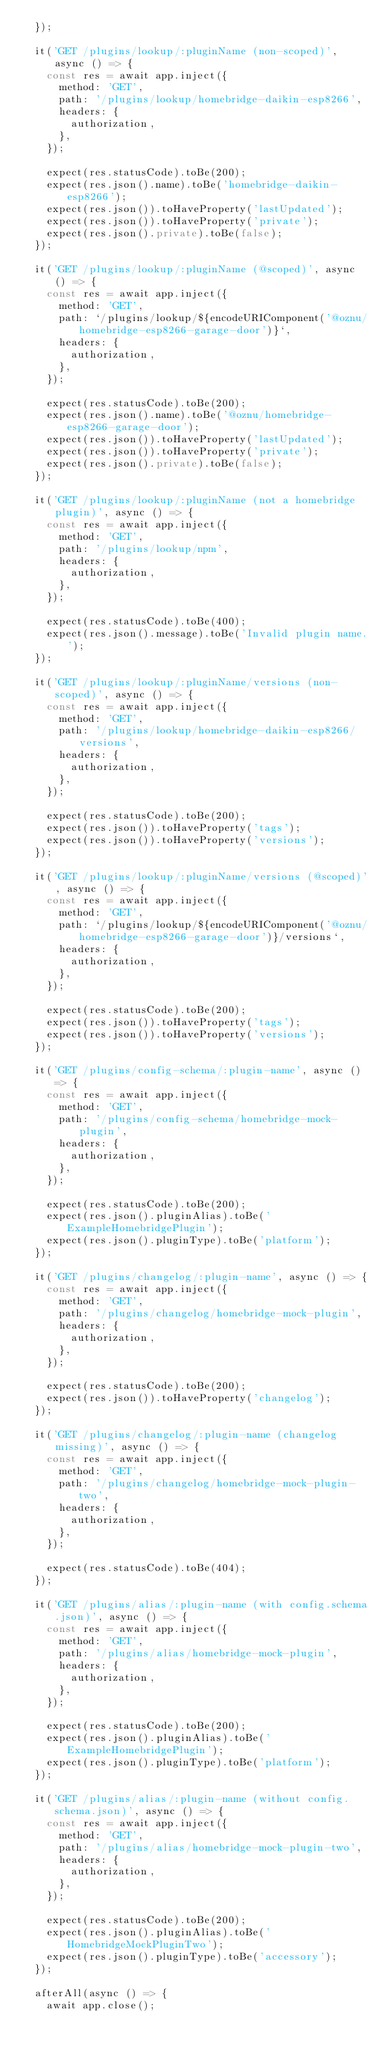<code> <loc_0><loc_0><loc_500><loc_500><_TypeScript_>  });

  it('GET /plugins/lookup/:pluginName (non-scoped)', async () => {
    const res = await app.inject({
      method: 'GET',
      path: '/plugins/lookup/homebridge-daikin-esp8266',
      headers: {
        authorization,
      },
    });

    expect(res.statusCode).toBe(200);
    expect(res.json().name).toBe('homebridge-daikin-esp8266');
    expect(res.json()).toHaveProperty('lastUpdated');
    expect(res.json()).toHaveProperty('private');
    expect(res.json().private).toBe(false);
  });

  it('GET /plugins/lookup/:pluginName (@scoped)', async () => {
    const res = await app.inject({
      method: 'GET',
      path: `/plugins/lookup/${encodeURIComponent('@oznu/homebridge-esp8266-garage-door')}`,
      headers: {
        authorization,
      },
    });

    expect(res.statusCode).toBe(200);
    expect(res.json().name).toBe('@oznu/homebridge-esp8266-garage-door');
    expect(res.json()).toHaveProperty('lastUpdated');
    expect(res.json()).toHaveProperty('private');
    expect(res.json().private).toBe(false);
  });

  it('GET /plugins/lookup/:pluginName (not a homebridge plugin)', async () => {
    const res = await app.inject({
      method: 'GET',
      path: '/plugins/lookup/npm',
      headers: {
        authorization,
      },
    });

    expect(res.statusCode).toBe(400);
    expect(res.json().message).toBe('Invalid plugin name.');
  });

  it('GET /plugins/lookup/:pluginName/versions (non-scoped)', async () => {
    const res = await app.inject({
      method: 'GET',
      path: '/plugins/lookup/homebridge-daikin-esp8266/versions',
      headers: {
        authorization,
      },
    });

    expect(res.statusCode).toBe(200);
    expect(res.json()).toHaveProperty('tags');
    expect(res.json()).toHaveProperty('versions');
  });

  it('GET /plugins/lookup/:pluginName/versions (@scoped)', async () => {
    const res = await app.inject({
      method: 'GET',
      path: `/plugins/lookup/${encodeURIComponent('@oznu/homebridge-esp8266-garage-door')}/versions`,
      headers: {
        authorization,
      },
    });

    expect(res.statusCode).toBe(200);
    expect(res.json()).toHaveProperty('tags');
    expect(res.json()).toHaveProperty('versions');
  });

  it('GET /plugins/config-schema/:plugin-name', async () => {
    const res = await app.inject({
      method: 'GET',
      path: '/plugins/config-schema/homebridge-mock-plugin',
      headers: {
        authorization,
      },
    });

    expect(res.statusCode).toBe(200);
    expect(res.json().pluginAlias).toBe('ExampleHomebridgePlugin');
    expect(res.json().pluginType).toBe('platform');
  });

  it('GET /plugins/changelog/:plugin-name', async () => {
    const res = await app.inject({
      method: 'GET',
      path: '/plugins/changelog/homebridge-mock-plugin',
      headers: {
        authorization,
      },
    });

    expect(res.statusCode).toBe(200);
    expect(res.json()).toHaveProperty('changelog');
  });

  it('GET /plugins/changelog/:plugin-name (changelog missing)', async () => {
    const res = await app.inject({
      method: 'GET',
      path: '/plugins/changelog/homebridge-mock-plugin-two',
      headers: {
        authorization,
      },
    });

    expect(res.statusCode).toBe(404);
  });

  it('GET /plugins/alias/:plugin-name (with config.schema.json)', async () => {
    const res = await app.inject({
      method: 'GET',
      path: '/plugins/alias/homebridge-mock-plugin',
      headers: {
        authorization,
      },
    });

    expect(res.statusCode).toBe(200);
    expect(res.json().pluginAlias).toBe('ExampleHomebridgePlugin');
    expect(res.json().pluginType).toBe('platform');
  });

  it('GET /plugins/alias/:plugin-name (without config.schema.json)', async () => {
    const res = await app.inject({
      method: 'GET',
      path: '/plugins/alias/homebridge-mock-plugin-two',
      headers: {
        authorization,
      },
    });

    expect(res.statusCode).toBe(200);
    expect(res.json().pluginAlias).toBe('HomebridgeMockPluginTwo');
    expect(res.json().pluginType).toBe('accessory');
  });

  afterAll(async () => {
    await app.close();</code> 